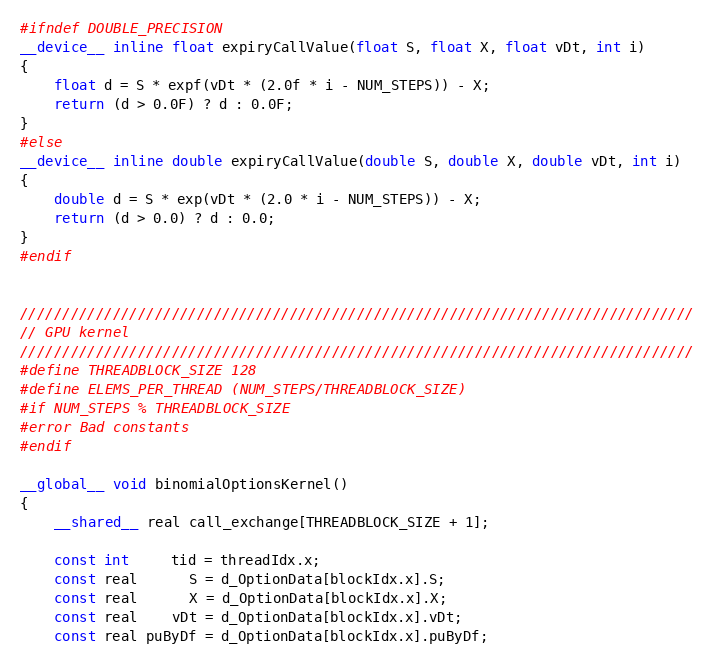<code> <loc_0><loc_0><loc_500><loc_500><_Cuda_>#ifndef DOUBLE_PRECISION
__device__ inline float expiryCallValue(float S, float X, float vDt, int i)
{
    float d = S * expf(vDt * (2.0f * i - NUM_STEPS)) - X;
    return (d > 0.0F) ? d : 0.0F;
}
#else
__device__ inline double expiryCallValue(double S, double X, double vDt, int i)
{
    double d = S * exp(vDt * (2.0 * i - NUM_STEPS)) - X;
    return (d > 0.0) ? d : 0.0;
}
#endif


////////////////////////////////////////////////////////////////////////////////
// GPU kernel
////////////////////////////////////////////////////////////////////////////////
#define THREADBLOCK_SIZE 128
#define ELEMS_PER_THREAD (NUM_STEPS/THREADBLOCK_SIZE)
#if NUM_STEPS % THREADBLOCK_SIZE
#error Bad constants
#endif

__global__ void binomialOptionsKernel()
{
    __shared__ real call_exchange[THREADBLOCK_SIZE + 1];

    const int     tid = threadIdx.x;
    const real      S = d_OptionData[blockIdx.x].S;
    const real      X = d_OptionData[blockIdx.x].X;
    const real    vDt = d_OptionData[blockIdx.x].vDt;
    const real puByDf = d_OptionData[blockIdx.x].puByDf;</code> 